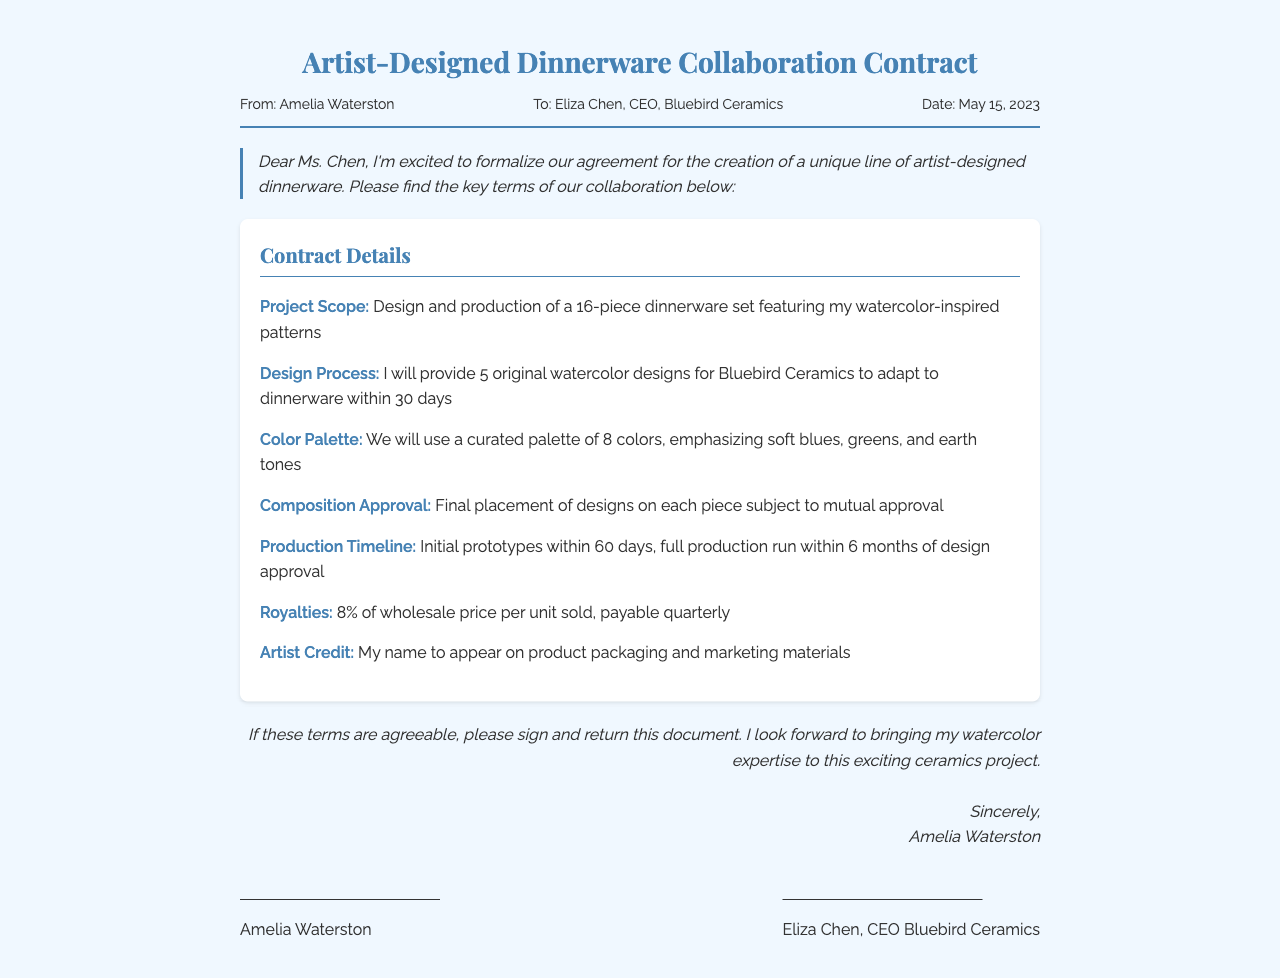what is the title of the document? The title of the document is clearly stated at the top and is "Artist-Designed Dinnerware Collaboration Contract."
Answer: Artist-Designed Dinnerware Collaboration Contract who is the sender of the fax? The sender, Amelia Waterston, is mentioned at the top of the document in the sender's section.
Answer: Amelia Waterston what is the date of the fax? The date is provided in the header details, which identifies the date this fax was sent.
Answer: May 15, 2023 what is the royalty percentage? The document specifies the percentage of royalties to be paid per unit sold in the contract details section.
Answer: 8% how many designs will the artist provide? The details about the number of designs provided by the artist can be found in the "Design Process" section of the document.
Answer: 5 what is the focus of the color palette? The color palette is described in the contract details, highlighting specific colors that will be used in the designs.
Answer: Soft blues, greens, and earth tones how long do initial prototypes take? The timeline for initial prototypes is mentioned in the "Production Timeline" section of the document.
Answer: 60 days who should sign the contract? The document outlines who is required to sign to formalize the agreement, which is evident in the signature section.
Answer: Amelia Waterston and Eliza Chen what type of document is this? The type of document is specified within its title and is characterized by its purpose and structure.
Answer: Fax 